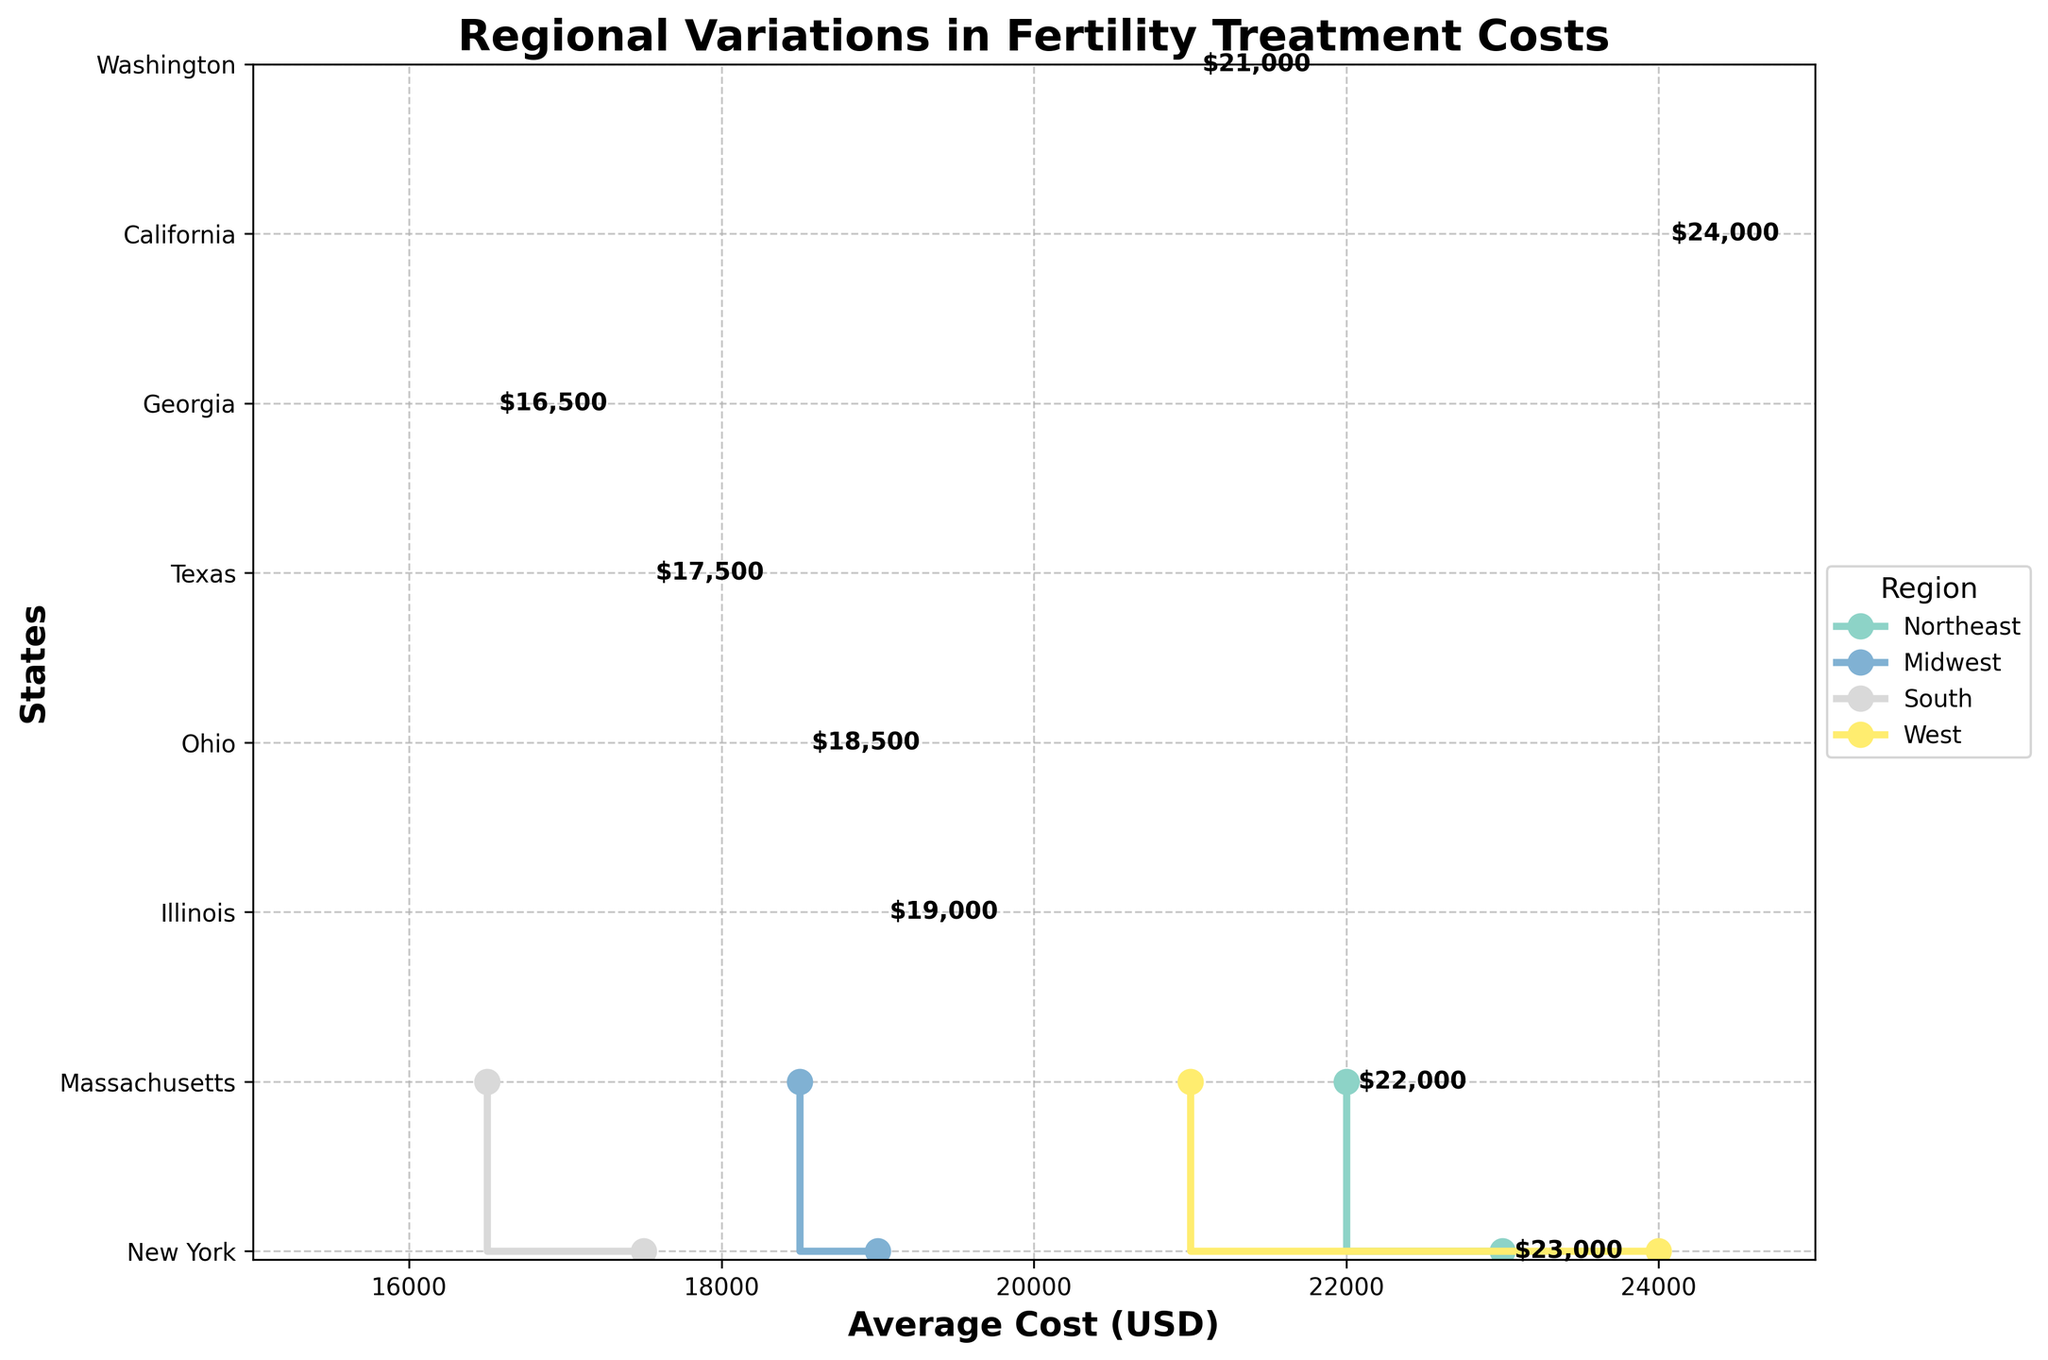What is the title of the plot? The title is typically displayed prominently at the top of the figure. In this case, it reads "Regional Variations in Fertility Treatment Costs".
Answer: Regional Variations in Fertility Treatment Costs Which region has the highest average cost for fertility treatments? Look at the highest points (rightmost) in the plot and check their corresponding region labels. The highest average cost is $24,000 which corresponds to California in the West region.
Answer: West What is the range of average costs for fertility treatments in the South region? Identify the range of average cost values for the South region by locating Texas ($17,500) and Georgia ($16,500) on the plot. The minimum is $16,500 and the maximum is $17,500.
Answer: $16,500 to $17,500 Which state has the lowest average cost for fertility treatments? Find the leftmost point on the x-axis of the plot to determine the state. This is Georgia, with an average cost of $16,500.
Answer: Georgia How does the average cost of fertility treatments in New York compare to that in California? Identify the points for New York and California. New York has an average cost of $23,000 while California has an average cost of $24,000. New York's cost is $1,000 less than California's.
Answer: New York's average cost is $1,000 less than California's What is the average cost difference between the Northeast and Midwest regions? Calculate the average of the costs for the Northeast and the Midwest. For Northeast: (23000 + 22000) / 2 = 22500. For Midwest: (19000 + 18500) / 2 = 18750. The difference is 22500 - 18750 = 3750.
Answer: $3,750 Which state in the Northeast has a higher average cost for fertility treatments? Compare the average costs for New York and Massachusetts within the Northeast region. New York has a cost of $23,000 and Massachusetts has $22,000. Thus, New York has a higher cost.
Answer: New York How many states have a "High" availability of fertility treatments? Count the data points associated with "High" availability, which corresponds to New York, Massachusetts, California, and Washington. There are 4 states with high availability.
Answer: 4 In which region is the difference in average costs between the states the largest? Compare the differences in costs within each region. The largest difference is in the West where California ($24,000) and Washington ($21,000) have a $3,000 difference. All other regions have smaller differences.
Answer: West What is the total average cost for fertility treatments across all states? Sum the average costs for all states: 23000 + 22000 + 19000 + 18500 + 17500 + 16500 + 24000 + 21000 = 161500.
Answer: $161,500 